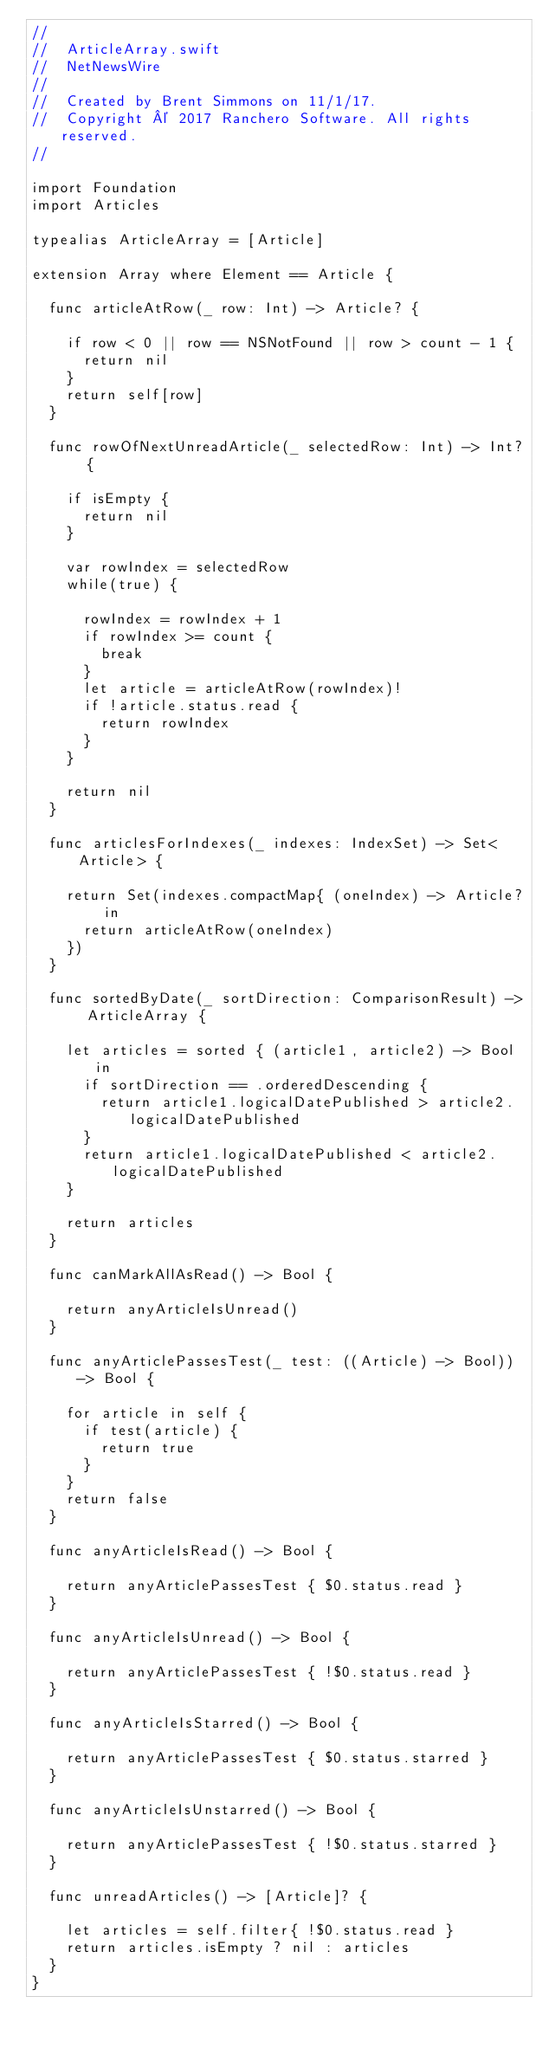<code> <loc_0><loc_0><loc_500><loc_500><_Swift_>//
//  ArticleArray.swift
//  NetNewsWire
//
//  Created by Brent Simmons on 11/1/17.
//  Copyright © 2017 Ranchero Software. All rights reserved.
//

import Foundation
import Articles

typealias ArticleArray = [Article]

extension Array where Element == Article {

	func articleAtRow(_ row: Int) -> Article? {

		if row < 0 || row == NSNotFound || row > count - 1 {
			return nil
		}
		return self[row]
	}

	func rowOfNextUnreadArticle(_ selectedRow: Int) -> Int? {

		if isEmpty {
			return nil
		}

		var rowIndex = selectedRow
		while(true) {

			rowIndex = rowIndex + 1
			if rowIndex >= count {
				break
			}
			let article = articleAtRow(rowIndex)!
			if !article.status.read {
				return rowIndex
			}
		}

		return nil
	}

	func articlesForIndexes(_ indexes: IndexSet) -> Set<Article> {

		return Set(indexes.compactMap{ (oneIndex) -> Article? in
			return articleAtRow(oneIndex)
		})
	}

	func sortedByDate(_ sortDirection: ComparisonResult) -> ArticleArray {

		let articles = sorted { (article1, article2) -> Bool in
			if sortDirection == .orderedDescending {
				return article1.logicalDatePublished > article2.logicalDatePublished
			}
			return article1.logicalDatePublished < article2.logicalDatePublished
		}

		return articles
	}

	func canMarkAllAsRead() -> Bool {

		return anyArticleIsUnread()
	}

	func anyArticlePassesTest(_ test: ((Article) -> Bool)) -> Bool {

		for article in self {
			if test(article) {
				return true
			}
		}
		return false
	}

	func anyArticleIsRead() -> Bool {

		return anyArticlePassesTest { $0.status.read }
	}

	func anyArticleIsUnread() -> Bool {

		return anyArticlePassesTest { !$0.status.read }
	}

	func anyArticleIsStarred() -> Bool {

		return anyArticlePassesTest { $0.status.starred }
	}

	func anyArticleIsUnstarred() -> Bool {

		return anyArticlePassesTest { !$0.status.starred }
	}

	func unreadArticles() -> [Article]? {

		let articles = self.filter{ !$0.status.read }
		return articles.isEmpty ? nil : articles
	}
}

</code> 